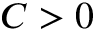<formula> <loc_0><loc_0><loc_500><loc_500>C > 0</formula> 